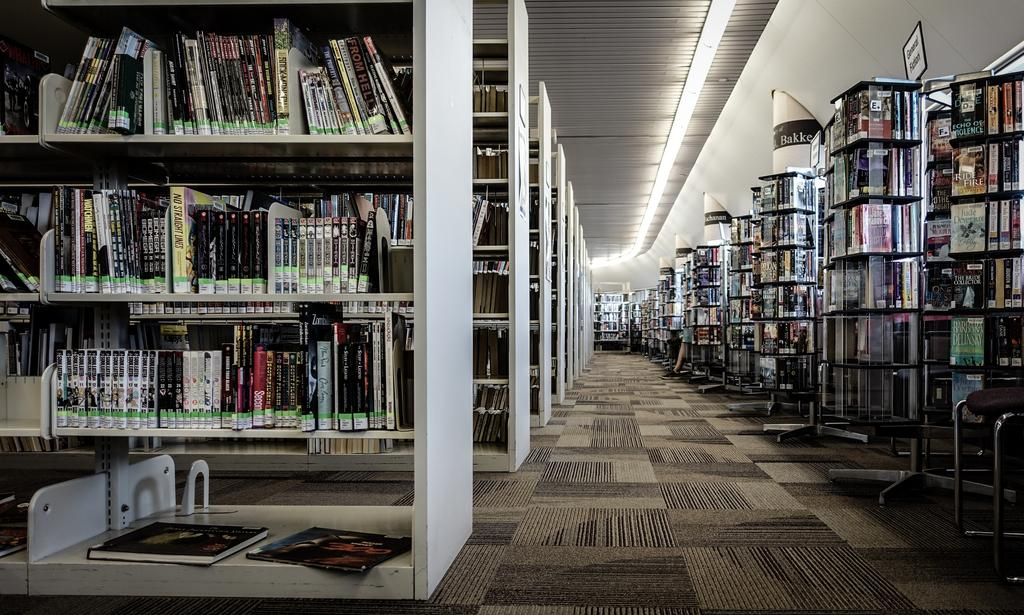What type of establishment is depicted in the image? The image shows the inside of a library. What can be found on the shelves in the library? There are books on the shelves in the library. Where can the ducks be found in the library? There are no ducks present in the library; the image only shows books on the shelves. 